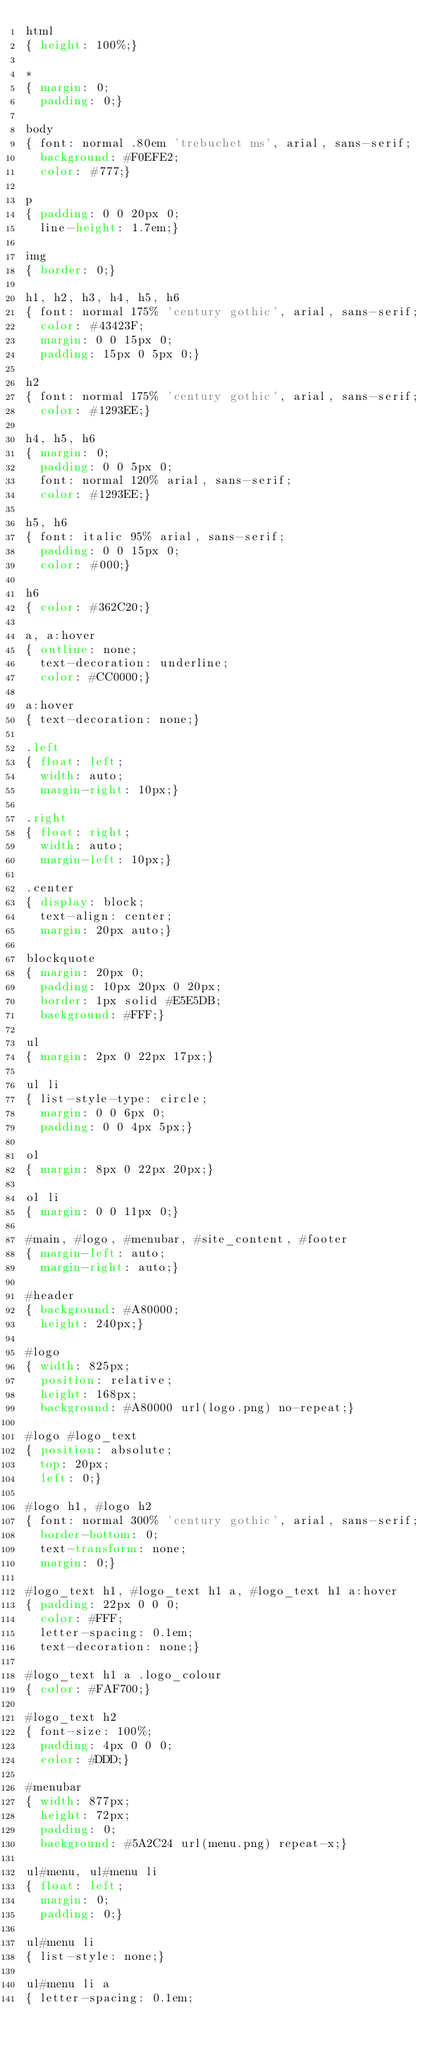<code> <loc_0><loc_0><loc_500><loc_500><_CSS_>html
{ height: 100%;}

*
{ margin: 0;
  padding: 0;}

body
{ font: normal .80em 'trebuchet ms', arial, sans-serif;
  background: #F0EFE2;
  color: #777;}

p
{ padding: 0 0 20px 0;
  line-height: 1.7em;}

img
{ border: 0;}

h1, h2, h3, h4, h5, h6 
{ font: normal 175% 'century gothic', arial, sans-serif;
  color: #43423F;
  margin: 0 0 15px 0;
  padding: 15px 0 5px 0;}

h2
{ font: normal 175% 'century gothic', arial, sans-serif;
  color: #1293EE;}

h4, h5, h6
{ margin: 0;
  padding: 0 0 5px 0;
  font: normal 120% arial, sans-serif;
  color: #1293EE;}

h5, h6
{ font: italic 95% arial, sans-serif;
  padding: 0 0 15px 0;
  color: #000;}

h6
{ color: #362C20;}

a, a:hover
{ outline: none;
  text-decoration: underline;
  color: #CC0000;}

a:hover
{ text-decoration: none;}

.left
{ float: left;
  width: auto;
  margin-right: 10px;}

.right
{ float: right; 
  width: auto;
  margin-left: 10px;}

.center
{ display: block;
  text-align: center;
  margin: 20px auto;}

blockquote
{ margin: 20px 0; 
  padding: 10px 20px 0 20px;
  border: 1px solid #E5E5DB;
  background: #FFF;}

ul
{ margin: 2px 0 22px 17px;}

ul li
{ list-style-type: circle;
  margin: 0 0 6px 0; 
  padding: 0 0 4px 5px;}

ol
{ margin: 8px 0 22px 20px;}

ol li
{ margin: 0 0 11px 0;}

#main, #logo, #menubar, #site_content, #footer
{ margin-left: auto; 
  margin-right: auto;}

#header
{ background: #A80000;
  height: 240px;}

#logo
{ width: 825px;
  position: relative;
  height: 168px;
  background: #A80000 url(logo.png) no-repeat;}

#logo #logo_text 
{ position: absolute; 
  top: 20px;
  left: 0;}

#logo h1, #logo h2
{ font: normal 300% 'century gothic', arial, sans-serif;
  border-bottom: 0;
  text-transform: none;
  margin: 0;}

#logo_text h1, #logo_text h1 a, #logo_text h1 a:hover 
{ padding: 22px 0 0 0;
  color: #FFF;
  letter-spacing: 0.1em;
  text-decoration: none;}

#logo_text h1 a .logo_colour
{ color: #FAF700;}

#logo_text h2
{ font-size: 100%;
  padding: 4px 0 0 0;
  color: #DDD;}

#menubar
{ width: 877px;
  height: 72px;
  padding: 0;
  background: #5A2C24 url(menu.png) repeat-x;} 

ul#menu, ul#menu li
{ float: left;
  margin: 0; 
  padding: 0;}

ul#menu li
{ list-style: none;}

ul#menu li a
{ letter-spacing: 0.1em;</code> 